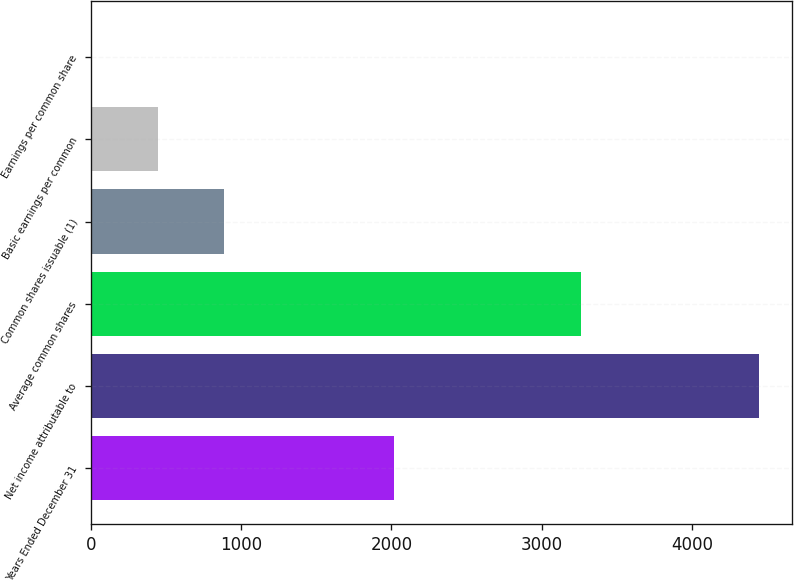<chart> <loc_0><loc_0><loc_500><loc_500><bar_chart><fcel>Years Ended December 31<fcel>Net income attributable to<fcel>Average common shares<fcel>Common shares issuable (1)<fcel>Basic earnings per common<fcel>Earnings per common share<nl><fcel>2015<fcel>4442<fcel>3260.04<fcel>889.64<fcel>445.6<fcel>1.56<nl></chart> 